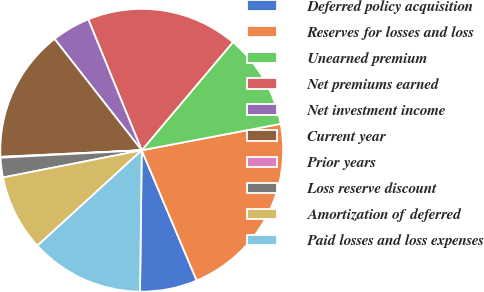Convert chart. <chart><loc_0><loc_0><loc_500><loc_500><pie_chart><fcel>Deferred policy acquisition<fcel>Reserves for losses and loss<fcel>Unearned premium<fcel>Net premiums earned<fcel>Net investment income<fcel>Current year<fcel>Prior years<fcel>Loss reserve discount<fcel>Amortization of deferred<fcel>Paid losses and loss expenses<nl><fcel>6.55%<fcel>21.63%<fcel>10.86%<fcel>17.32%<fcel>4.4%<fcel>15.17%<fcel>0.09%<fcel>2.25%<fcel>8.71%<fcel>13.01%<nl></chart> 